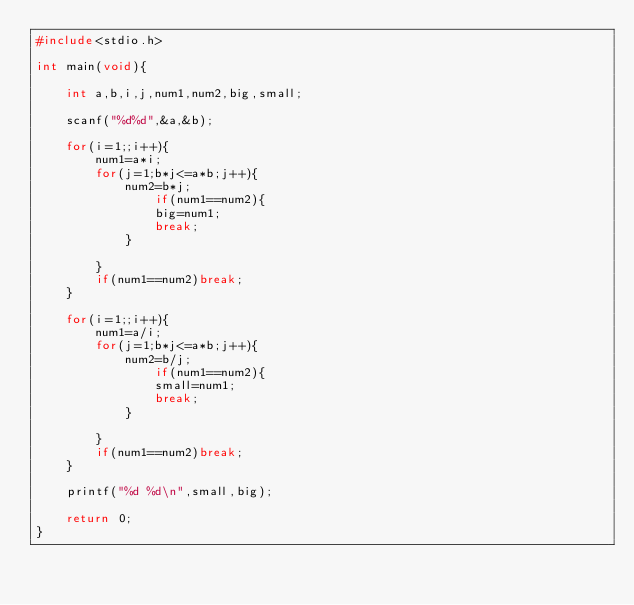<code> <loc_0><loc_0><loc_500><loc_500><_C_>#include<stdio.h>

int main(void){

	int a,b,i,j,num1,num2,big,small;
	
	scanf("%d%d",&a,&b);
	
	for(i=1;;i++){
		num1=a*i;
		for(j=1;b*j<=a*b;j++){
			num2=b*j;
				if(num1==num2){
				big=num1;
				break;
			}
			
		}
		if(num1==num2)break;
	}
	
	for(i=1;;i++){
		num1=a/i;
		for(j=1;b*j<=a*b;j++){
			num2=b/j;
				if(num1==num2){
				small=num1;
				break;
			}
			
		}
		if(num1==num2)break;
	}
	
	printf("%d %d\n",small,big);
	
	return 0;
}</code> 